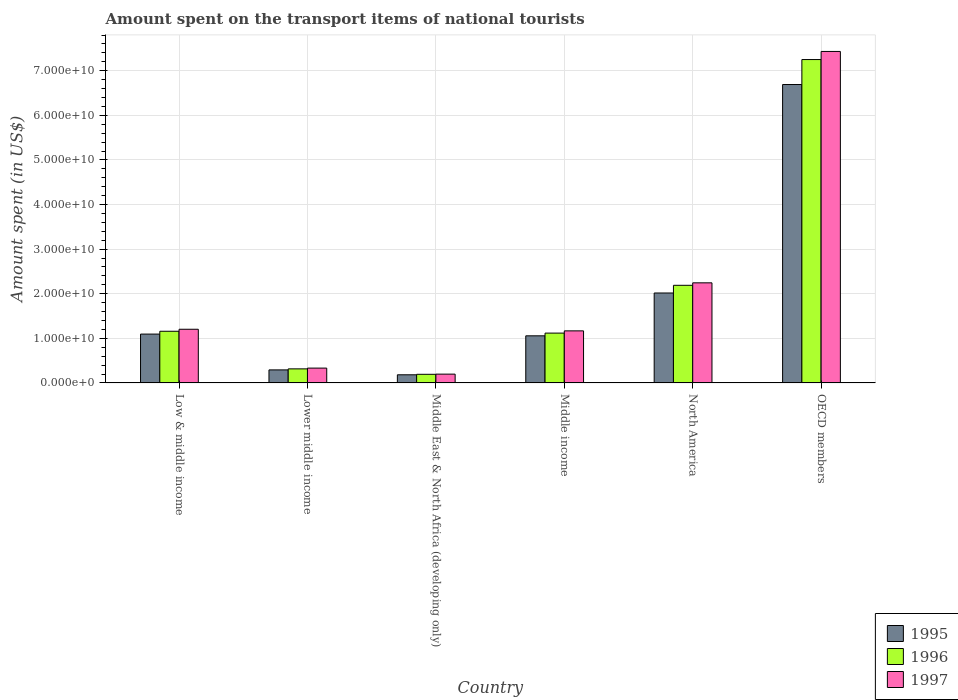How many different coloured bars are there?
Your answer should be very brief. 3. Are the number of bars on each tick of the X-axis equal?
Give a very brief answer. Yes. How many bars are there on the 1st tick from the right?
Provide a succinct answer. 3. What is the label of the 6th group of bars from the left?
Keep it short and to the point. OECD members. In how many cases, is the number of bars for a given country not equal to the number of legend labels?
Your response must be concise. 0. What is the amount spent on the transport items of national tourists in 1996 in Lower middle income?
Ensure brevity in your answer.  3.16e+09. Across all countries, what is the maximum amount spent on the transport items of national tourists in 1996?
Make the answer very short. 7.25e+1. Across all countries, what is the minimum amount spent on the transport items of national tourists in 1996?
Provide a short and direct response. 1.94e+09. In which country was the amount spent on the transport items of national tourists in 1995 minimum?
Ensure brevity in your answer.  Middle East & North Africa (developing only). What is the total amount spent on the transport items of national tourists in 1997 in the graph?
Offer a terse response. 1.26e+11. What is the difference between the amount spent on the transport items of national tourists in 1996 in Low & middle income and that in OECD members?
Your answer should be very brief. -6.09e+1. What is the difference between the amount spent on the transport items of national tourists in 1996 in North America and the amount spent on the transport items of national tourists in 1995 in OECD members?
Give a very brief answer. -4.50e+1. What is the average amount spent on the transport items of national tourists in 1997 per country?
Keep it short and to the point. 2.10e+1. What is the difference between the amount spent on the transport items of national tourists of/in 1996 and amount spent on the transport items of national tourists of/in 1995 in Lower middle income?
Keep it short and to the point. 2.31e+08. What is the ratio of the amount spent on the transport items of national tourists in 1995 in Middle East & North Africa (developing only) to that in OECD members?
Offer a very short reply. 0.03. Is the amount spent on the transport items of national tourists in 1996 in Low & middle income less than that in OECD members?
Keep it short and to the point. Yes. Is the difference between the amount spent on the transport items of national tourists in 1996 in Lower middle income and OECD members greater than the difference between the amount spent on the transport items of national tourists in 1995 in Lower middle income and OECD members?
Provide a short and direct response. No. What is the difference between the highest and the second highest amount spent on the transport items of national tourists in 1997?
Make the answer very short. 5.19e+1. What is the difference between the highest and the lowest amount spent on the transport items of national tourists in 1995?
Provide a short and direct response. 6.51e+1. In how many countries, is the amount spent on the transport items of national tourists in 1996 greater than the average amount spent on the transport items of national tourists in 1996 taken over all countries?
Offer a terse response. 2. Is the sum of the amount spent on the transport items of national tourists in 1996 in Middle East & North Africa (developing only) and North America greater than the maximum amount spent on the transport items of national tourists in 1997 across all countries?
Make the answer very short. No. What does the 1st bar from the right in OECD members represents?
Offer a terse response. 1997. Is it the case that in every country, the sum of the amount spent on the transport items of national tourists in 1997 and amount spent on the transport items of national tourists in 1995 is greater than the amount spent on the transport items of national tourists in 1996?
Give a very brief answer. Yes. How many bars are there?
Make the answer very short. 18. How many countries are there in the graph?
Your answer should be compact. 6. Does the graph contain any zero values?
Give a very brief answer. No. Does the graph contain grids?
Offer a terse response. Yes. How are the legend labels stacked?
Offer a terse response. Vertical. What is the title of the graph?
Provide a succinct answer. Amount spent on the transport items of national tourists. What is the label or title of the X-axis?
Your answer should be compact. Country. What is the label or title of the Y-axis?
Make the answer very short. Amount spent (in US$). What is the Amount spent (in US$) of 1995 in Low & middle income?
Your answer should be very brief. 1.10e+1. What is the Amount spent (in US$) of 1996 in Low & middle income?
Your answer should be very brief. 1.16e+1. What is the Amount spent (in US$) in 1997 in Low & middle income?
Make the answer very short. 1.20e+1. What is the Amount spent (in US$) of 1995 in Lower middle income?
Offer a very short reply. 2.92e+09. What is the Amount spent (in US$) in 1996 in Lower middle income?
Your answer should be very brief. 3.16e+09. What is the Amount spent (in US$) of 1997 in Lower middle income?
Your response must be concise. 3.33e+09. What is the Amount spent (in US$) of 1995 in Middle East & North Africa (developing only)?
Your response must be concise. 1.83e+09. What is the Amount spent (in US$) in 1996 in Middle East & North Africa (developing only)?
Your answer should be compact. 1.94e+09. What is the Amount spent (in US$) in 1997 in Middle East & North Africa (developing only)?
Keep it short and to the point. 1.97e+09. What is the Amount spent (in US$) of 1995 in Middle income?
Make the answer very short. 1.06e+1. What is the Amount spent (in US$) in 1996 in Middle income?
Provide a succinct answer. 1.12e+1. What is the Amount spent (in US$) in 1997 in Middle income?
Provide a succinct answer. 1.17e+1. What is the Amount spent (in US$) of 1995 in North America?
Ensure brevity in your answer.  2.02e+1. What is the Amount spent (in US$) in 1996 in North America?
Provide a short and direct response. 2.19e+1. What is the Amount spent (in US$) of 1997 in North America?
Offer a terse response. 2.24e+1. What is the Amount spent (in US$) of 1995 in OECD members?
Ensure brevity in your answer.  6.69e+1. What is the Amount spent (in US$) in 1996 in OECD members?
Provide a short and direct response. 7.25e+1. What is the Amount spent (in US$) in 1997 in OECD members?
Provide a succinct answer. 7.43e+1. Across all countries, what is the maximum Amount spent (in US$) in 1995?
Your response must be concise. 6.69e+1. Across all countries, what is the maximum Amount spent (in US$) of 1996?
Your answer should be very brief. 7.25e+1. Across all countries, what is the maximum Amount spent (in US$) of 1997?
Keep it short and to the point. 7.43e+1. Across all countries, what is the minimum Amount spent (in US$) of 1995?
Your response must be concise. 1.83e+09. Across all countries, what is the minimum Amount spent (in US$) in 1996?
Your response must be concise. 1.94e+09. Across all countries, what is the minimum Amount spent (in US$) in 1997?
Make the answer very short. 1.97e+09. What is the total Amount spent (in US$) of 1995 in the graph?
Give a very brief answer. 1.13e+11. What is the total Amount spent (in US$) of 1996 in the graph?
Your response must be concise. 1.22e+11. What is the total Amount spent (in US$) in 1997 in the graph?
Your response must be concise. 1.26e+11. What is the difference between the Amount spent (in US$) of 1995 in Low & middle income and that in Lower middle income?
Your answer should be very brief. 8.03e+09. What is the difference between the Amount spent (in US$) in 1996 in Low & middle income and that in Lower middle income?
Make the answer very short. 8.43e+09. What is the difference between the Amount spent (in US$) of 1997 in Low & middle income and that in Lower middle income?
Provide a short and direct response. 8.71e+09. What is the difference between the Amount spent (in US$) of 1995 in Low & middle income and that in Middle East & North Africa (developing only)?
Your answer should be very brief. 9.13e+09. What is the difference between the Amount spent (in US$) of 1996 in Low & middle income and that in Middle East & North Africa (developing only)?
Ensure brevity in your answer.  9.65e+09. What is the difference between the Amount spent (in US$) of 1997 in Low & middle income and that in Middle East & North Africa (developing only)?
Ensure brevity in your answer.  1.01e+1. What is the difference between the Amount spent (in US$) in 1995 in Low & middle income and that in Middle income?
Offer a terse response. 3.88e+08. What is the difference between the Amount spent (in US$) of 1996 in Low & middle income and that in Middle income?
Your answer should be very brief. 4.14e+08. What is the difference between the Amount spent (in US$) of 1997 in Low & middle income and that in Middle income?
Provide a short and direct response. 3.62e+08. What is the difference between the Amount spent (in US$) of 1995 in Low & middle income and that in North America?
Your answer should be very brief. -9.21e+09. What is the difference between the Amount spent (in US$) in 1996 in Low & middle income and that in North America?
Your answer should be very brief. -1.03e+1. What is the difference between the Amount spent (in US$) in 1997 in Low & middle income and that in North America?
Your response must be concise. -1.04e+1. What is the difference between the Amount spent (in US$) of 1995 in Low & middle income and that in OECD members?
Your response must be concise. -5.60e+1. What is the difference between the Amount spent (in US$) of 1996 in Low & middle income and that in OECD members?
Offer a terse response. -6.09e+1. What is the difference between the Amount spent (in US$) of 1997 in Low & middle income and that in OECD members?
Ensure brevity in your answer.  -6.23e+1. What is the difference between the Amount spent (in US$) in 1995 in Lower middle income and that in Middle East & North Africa (developing only)?
Your response must be concise. 1.10e+09. What is the difference between the Amount spent (in US$) in 1996 in Lower middle income and that in Middle East & North Africa (developing only)?
Ensure brevity in your answer.  1.22e+09. What is the difference between the Amount spent (in US$) in 1997 in Lower middle income and that in Middle East & North Africa (developing only)?
Your response must be concise. 1.35e+09. What is the difference between the Amount spent (in US$) of 1995 in Lower middle income and that in Middle income?
Your answer should be compact. -7.64e+09. What is the difference between the Amount spent (in US$) in 1996 in Lower middle income and that in Middle income?
Give a very brief answer. -8.02e+09. What is the difference between the Amount spent (in US$) in 1997 in Lower middle income and that in Middle income?
Keep it short and to the point. -8.35e+09. What is the difference between the Amount spent (in US$) of 1995 in Lower middle income and that in North America?
Your answer should be very brief. -1.72e+1. What is the difference between the Amount spent (in US$) in 1996 in Lower middle income and that in North America?
Provide a succinct answer. -1.87e+1. What is the difference between the Amount spent (in US$) in 1997 in Lower middle income and that in North America?
Offer a very short reply. -1.91e+1. What is the difference between the Amount spent (in US$) in 1995 in Lower middle income and that in OECD members?
Provide a succinct answer. -6.40e+1. What is the difference between the Amount spent (in US$) of 1996 in Lower middle income and that in OECD members?
Keep it short and to the point. -6.94e+1. What is the difference between the Amount spent (in US$) in 1997 in Lower middle income and that in OECD members?
Keep it short and to the point. -7.10e+1. What is the difference between the Amount spent (in US$) in 1995 in Middle East & North Africa (developing only) and that in Middle income?
Ensure brevity in your answer.  -8.74e+09. What is the difference between the Amount spent (in US$) of 1996 in Middle East & North Africa (developing only) and that in Middle income?
Give a very brief answer. -9.24e+09. What is the difference between the Amount spent (in US$) in 1997 in Middle East & North Africa (developing only) and that in Middle income?
Provide a short and direct response. -9.70e+09. What is the difference between the Amount spent (in US$) in 1995 in Middle East & North Africa (developing only) and that in North America?
Provide a short and direct response. -1.83e+1. What is the difference between the Amount spent (in US$) of 1996 in Middle East & North Africa (developing only) and that in North America?
Provide a succinct answer. -2.00e+1. What is the difference between the Amount spent (in US$) in 1997 in Middle East & North Africa (developing only) and that in North America?
Your response must be concise. -2.05e+1. What is the difference between the Amount spent (in US$) of 1995 in Middle East & North Africa (developing only) and that in OECD members?
Offer a terse response. -6.51e+1. What is the difference between the Amount spent (in US$) in 1996 in Middle East & North Africa (developing only) and that in OECD members?
Make the answer very short. -7.06e+1. What is the difference between the Amount spent (in US$) of 1997 in Middle East & North Africa (developing only) and that in OECD members?
Keep it short and to the point. -7.24e+1. What is the difference between the Amount spent (in US$) in 1995 in Middle income and that in North America?
Provide a succinct answer. -9.60e+09. What is the difference between the Amount spent (in US$) in 1996 in Middle income and that in North America?
Your response must be concise. -1.07e+1. What is the difference between the Amount spent (in US$) of 1997 in Middle income and that in North America?
Give a very brief answer. -1.08e+1. What is the difference between the Amount spent (in US$) of 1995 in Middle income and that in OECD members?
Ensure brevity in your answer.  -5.63e+1. What is the difference between the Amount spent (in US$) in 1996 in Middle income and that in OECD members?
Keep it short and to the point. -6.13e+1. What is the difference between the Amount spent (in US$) in 1997 in Middle income and that in OECD members?
Make the answer very short. -6.27e+1. What is the difference between the Amount spent (in US$) in 1995 in North America and that in OECD members?
Provide a succinct answer. -4.67e+1. What is the difference between the Amount spent (in US$) in 1996 in North America and that in OECD members?
Offer a terse response. -5.06e+1. What is the difference between the Amount spent (in US$) in 1997 in North America and that in OECD members?
Keep it short and to the point. -5.19e+1. What is the difference between the Amount spent (in US$) of 1995 in Low & middle income and the Amount spent (in US$) of 1996 in Lower middle income?
Your answer should be very brief. 7.80e+09. What is the difference between the Amount spent (in US$) of 1995 in Low & middle income and the Amount spent (in US$) of 1997 in Lower middle income?
Give a very brief answer. 7.63e+09. What is the difference between the Amount spent (in US$) in 1996 in Low & middle income and the Amount spent (in US$) in 1997 in Lower middle income?
Your response must be concise. 8.26e+09. What is the difference between the Amount spent (in US$) in 1995 in Low & middle income and the Amount spent (in US$) in 1996 in Middle East & North Africa (developing only)?
Offer a very short reply. 9.02e+09. What is the difference between the Amount spent (in US$) in 1995 in Low & middle income and the Amount spent (in US$) in 1997 in Middle East & North Africa (developing only)?
Make the answer very short. 8.98e+09. What is the difference between the Amount spent (in US$) of 1996 in Low & middle income and the Amount spent (in US$) of 1997 in Middle East & North Africa (developing only)?
Your answer should be compact. 9.61e+09. What is the difference between the Amount spent (in US$) of 1995 in Low & middle income and the Amount spent (in US$) of 1996 in Middle income?
Your answer should be compact. -2.19e+08. What is the difference between the Amount spent (in US$) in 1995 in Low & middle income and the Amount spent (in US$) in 1997 in Middle income?
Make the answer very short. -7.20e+08. What is the difference between the Amount spent (in US$) of 1996 in Low & middle income and the Amount spent (in US$) of 1997 in Middle income?
Your response must be concise. -8.74e+07. What is the difference between the Amount spent (in US$) in 1995 in Low & middle income and the Amount spent (in US$) in 1996 in North America?
Ensure brevity in your answer.  -1.09e+1. What is the difference between the Amount spent (in US$) in 1995 in Low & middle income and the Amount spent (in US$) in 1997 in North America?
Make the answer very short. -1.15e+1. What is the difference between the Amount spent (in US$) of 1996 in Low & middle income and the Amount spent (in US$) of 1997 in North America?
Provide a succinct answer. -1.09e+1. What is the difference between the Amount spent (in US$) of 1995 in Low & middle income and the Amount spent (in US$) of 1996 in OECD members?
Provide a succinct answer. -6.16e+1. What is the difference between the Amount spent (in US$) of 1995 in Low & middle income and the Amount spent (in US$) of 1997 in OECD members?
Offer a terse response. -6.34e+1. What is the difference between the Amount spent (in US$) of 1996 in Low & middle income and the Amount spent (in US$) of 1997 in OECD members?
Your answer should be very brief. -6.27e+1. What is the difference between the Amount spent (in US$) of 1995 in Lower middle income and the Amount spent (in US$) of 1996 in Middle East & North Africa (developing only)?
Keep it short and to the point. 9.90e+08. What is the difference between the Amount spent (in US$) in 1995 in Lower middle income and the Amount spent (in US$) in 1997 in Middle East & North Africa (developing only)?
Offer a terse response. 9.50e+08. What is the difference between the Amount spent (in US$) of 1996 in Lower middle income and the Amount spent (in US$) of 1997 in Middle East & North Africa (developing only)?
Give a very brief answer. 1.18e+09. What is the difference between the Amount spent (in US$) in 1995 in Lower middle income and the Amount spent (in US$) in 1996 in Middle income?
Give a very brief answer. -8.25e+09. What is the difference between the Amount spent (in US$) of 1995 in Lower middle income and the Amount spent (in US$) of 1997 in Middle income?
Keep it short and to the point. -8.75e+09. What is the difference between the Amount spent (in US$) of 1996 in Lower middle income and the Amount spent (in US$) of 1997 in Middle income?
Your answer should be compact. -8.52e+09. What is the difference between the Amount spent (in US$) of 1995 in Lower middle income and the Amount spent (in US$) of 1996 in North America?
Give a very brief answer. -1.90e+1. What is the difference between the Amount spent (in US$) in 1995 in Lower middle income and the Amount spent (in US$) in 1997 in North America?
Your answer should be very brief. -1.95e+1. What is the difference between the Amount spent (in US$) of 1996 in Lower middle income and the Amount spent (in US$) of 1997 in North America?
Offer a terse response. -1.93e+1. What is the difference between the Amount spent (in US$) in 1995 in Lower middle income and the Amount spent (in US$) in 1996 in OECD members?
Offer a terse response. -6.96e+1. What is the difference between the Amount spent (in US$) in 1995 in Lower middle income and the Amount spent (in US$) in 1997 in OECD members?
Offer a terse response. -7.14e+1. What is the difference between the Amount spent (in US$) in 1996 in Lower middle income and the Amount spent (in US$) in 1997 in OECD members?
Keep it short and to the point. -7.12e+1. What is the difference between the Amount spent (in US$) of 1995 in Middle East & North Africa (developing only) and the Amount spent (in US$) of 1996 in Middle income?
Give a very brief answer. -9.35e+09. What is the difference between the Amount spent (in US$) in 1995 in Middle East & North Africa (developing only) and the Amount spent (in US$) in 1997 in Middle income?
Your answer should be compact. -9.85e+09. What is the difference between the Amount spent (in US$) in 1996 in Middle East & North Africa (developing only) and the Amount spent (in US$) in 1997 in Middle income?
Keep it short and to the point. -9.74e+09. What is the difference between the Amount spent (in US$) of 1995 in Middle East & North Africa (developing only) and the Amount spent (in US$) of 1996 in North America?
Your answer should be compact. -2.01e+1. What is the difference between the Amount spent (in US$) in 1995 in Middle East & North Africa (developing only) and the Amount spent (in US$) in 1997 in North America?
Keep it short and to the point. -2.06e+1. What is the difference between the Amount spent (in US$) in 1996 in Middle East & North Africa (developing only) and the Amount spent (in US$) in 1997 in North America?
Make the answer very short. -2.05e+1. What is the difference between the Amount spent (in US$) in 1995 in Middle East & North Africa (developing only) and the Amount spent (in US$) in 1996 in OECD members?
Make the answer very short. -7.07e+1. What is the difference between the Amount spent (in US$) of 1995 in Middle East & North Africa (developing only) and the Amount spent (in US$) of 1997 in OECD members?
Provide a short and direct response. -7.25e+1. What is the difference between the Amount spent (in US$) of 1996 in Middle East & North Africa (developing only) and the Amount spent (in US$) of 1997 in OECD members?
Your response must be concise. -7.24e+1. What is the difference between the Amount spent (in US$) in 1995 in Middle income and the Amount spent (in US$) in 1996 in North America?
Make the answer very short. -1.13e+1. What is the difference between the Amount spent (in US$) in 1995 in Middle income and the Amount spent (in US$) in 1997 in North America?
Give a very brief answer. -1.19e+1. What is the difference between the Amount spent (in US$) in 1996 in Middle income and the Amount spent (in US$) in 1997 in North America?
Provide a short and direct response. -1.13e+1. What is the difference between the Amount spent (in US$) in 1995 in Middle income and the Amount spent (in US$) in 1996 in OECD members?
Provide a succinct answer. -6.19e+1. What is the difference between the Amount spent (in US$) of 1995 in Middle income and the Amount spent (in US$) of 1997 in OECD members?
Offer a terse response. -6.38e+1. What is the difference between the Amount spent (in US$) of 1996 in Middle income and the Amount spent (in US$) of 1997 in OECD members?
Provide a succinct answer. -6.32e+1. What is the difference between the Amount spent (in US$) of 1995 in North America and the Amount spent (in US$) of 1996 in OECD members?
Offer a very short reply. -5.23e+1. What is the difference between the Amount spent (in US$) of 1995 in North America and the Amount spent (in US$) of 1997 in OECD members?
Make the answer very short. -5.42e+1. What is the difference between the Amount spent (in US$) of 1996 in North America and the Amount spent (in US$) of 1997 in OECD members?
Make the answer very short. -5.24e+1. What is the average Amount spent (in US$) in 1995 per country?
Ensure brevity in your answer.  1.89e+1. What is the average Amount spent (in US$) in 1996 per country?
Your response must be concise. 2.04e+1. What is the average Amount spent (in US$) in 1997 per country?
Ensure brevity in your answer.  2.10e+1. What is the difference between the Amount spent (in US$) in 1995 and Amount spent (in US$) in 1996 in Low & middle income?
Provide a short and direct response. -6.33e+08. What is the difference between the Amount spent (in US$) in 1995 and Amount spent (in US$) in 1997 in Low & middle income?
Your answer should be compact. -1.08e+09. What is the difference between the Amount spent (in US$) of 1996 and Amount spent (in US$) of 1997 in Low & middle income?
Provide a short and direct response. -4.49e+08. What is the difference between the Amount spent (in US$) of 1995 and Amount spent (in US$) of 1996 in Lower middle income?
Your answer should be compact. -2.31e+08. What is the difference between the Amount spent (in US$) of 1995 and Amount spent (in US$) of 1997 in Lower middle income?
Make the answer very short. -4.03e+08. What is the difference between the Amount spent (in US$) of 1996 and Amount spent (in US$) of 1997 in Lower middle income?
Your response must be concise. -1.73e+08. What is the difference between the Amount spent (in US$) of 1995 and Amount spent (in US$) of 1996 in Middle East & North Africa (developing only)?
Your answer should be very brief. -1.08e+08. What is the difference between the Amount spent (in US$) of 1995 and Amount spent (in US$) of 1997 in Middle East & North Africa (developing only)?
Your response must be concise. -1.47e+08. What is the difference between the Amount spent (in US$) of 1996 and Amount spent (in US$) of 1997 in Middle East & North Africa (developing only)?
Ensure brevity in your answer.  -3.92e+07. What is the difference between the Amount spent (in US$) in 1995 and Amount spent (in US$) in 1996 in Middle income?
Give a very brief answer. -6.08e+08. What is the difference between the Amount spent (in US$) of 1995 and Amount spent (in US$) of 1997 in Middle income?
Your answer should be compact. -1.11e+09. What is the difference between the Amount spent (in US$) in 1996 and Amount spent (in US$) in 1997 in Middle income?
Your answer should be compact. -5.01e+08. What is the difference between the Amount spent (in US$) in 1995 and Amount spent (in US$) in 1996 in North America?
Provide a succinct answer. -1.72e+09. What is the difference between the Amount spent (in US$) in 1995 and Amount spent (in US$) in 1997 in North America?
Your response must be concise. -2.28e+09. What is the difference between the Amount spent (in US$) of 1996 and Amount spent (in US$) of 1997 in North America?
Make the answer very short. -5.53e+08. What is the difference between the Amount spent (in US$) of 1995 and Amount spent (in US$) of 1996 in OECD members?
Offer a very short reply. -5.60e+09. What is the difference between the Amount spent (in US$) in 1995 and Amount spent (in US$) in 1997 in OECD members?
Your answer should be compact. -7.41e+09. What is the difference between the Amount spent (in US$) of 1996 and Amount spent (in US$) of 1997 in OECD members?
Offer a very short reply. -1.82e+09. What is the ratio of the Amount spent (in US$) in 1995 in Low & middle income to that in Lower middle income?
Your answer should be compact. 3.75. What is the ratio of the Amount spent (in US$) in 1996 in Low & middle income to that in Lower middle income?
Provide a short and direct response. 3.67. What is the ratio of the Amount spent (in US$) of 1997 in Low & middle income to that in Lower middle income?
Provide a succinct answer. 3.62. What is the ratio of the Amount spent (in US$) in 1995 in Low & middle income to that in Middle East & North Africa (developing only)?
Make the answer very short. 5.99. What is the ratio of the Amount spent (in US$) in 1996 in Low & middle income to that in Middle East & North Africa (developing only)?
Make the answer very short. 5.99. What is the ratio of the Amount spent (in US$) of 1997 in Low & middle income to that in Middle East & North Africa (developing only)?
Give a very brief answer. 6.1. What is the ratio of the Amount spent (in US$) of 1995 in Low & middle income to that in Middle income?
Offer a very short reply. 1.04. What is the ratio of the Amount spent (in US$) in 1996 in Low & middle income to that in Middle income?
Give a very brief answer. 1.04. What is the ratio of the Amount spent (in US$) in 1997 in Low & middle income to that in Middle income?
Provide a succinct answer. 1.03. What is the ratio of the Amount spent (in US$) of 1995 in Low & middle income to that in North America?
Your response must be concise. 0.54. What is the ratio of the Amount spent (in US$) in 1996 in Low & middle income to that in North America?
Provide a succinct answer. 0.53. What is the ratio of the Amount spent (in US$) of 1997 in Low & middle income to that in North America?
Your answer should be very brief. 0.54. What is the ratio of the Amount spent (in US$) in 1995 in Low & middle income to that in OECD members?
Your answer should be compact. 0.16. What is the ratio of the Amount spent (in US$) of 1996 in Low & middle income to that in OECD members?
Offer a very short reply. 0.16. What is the ratio of the Amount spent (in US$) in 1997 in Low & middle income to that in OECD members?
Your response must be concise. 0.16. What is the ratio of the Amount spent (in US$) in 1995 in Lower middle income to that in Middle East & North Africa (developing only)?
Give a very brief answer. 1.6. What is the ratio of the Amount spent (in US$) of 1996 in Lower middle income to that in Middle East & North Africa (developing only)?
Make the answer very short. 1.63. What is the ratio of the Amount spent (in US$) of 1997 in Lower middle income to that in Middle East & North Africa (developing only)?
Offer a very short reply. 1.69. What is the ratio of the Amount spent (in US$) of 1995 in Lower middle income to that in Middle income?
Offer a very short reply. 0.28. What is the ratio of the Amount spent (in US$) of 1996 in Lower middle income to that in Middle income?
Offer a terse response. 0.28. What is the ratio of the Amount spent (in US$) of 1997 in Lower middle income to that in Middle income?
Ensure brevity in your answer.  0.29. What is the ratio of the Amount spent (in US$) of 1995 in Lower middle income to that in North America?
Provide a short and direct response. 0.14. What is the ratio of the Amount spent (in US$) of 1996 in Lower middle income to that in North America?
Ensure brevity in your answer.  0.14. What is the ratio of the Amount spent (in US$) in 1997 in Lower middle income to that in North America?
Ensure brevity in your answer.  0.15. What is the ratio of the Amount spent (in US$) in 1995 in Lower middle income to that in OECD members?
Your response must be concise. 0.04. What is the ratio of the Amount spent (in US$) of 1996 in Lower middle income to that in OECD members?
Your answer should be compact. 0.04. What is the ratio of the Amount spent (in US$) in 1997 in Lower middle income to that in OECD members?
Keep it short and to the point. 0.04. What is the ratio of the Amount spent (in US$) of 1995 in Middle East & North Africa (developing only) to that in Middle income?
Keep it short and to the point. 0.17. What is the ratio of the Amount spent (in US$) in 1996 in Middle East & North Africa (developing only) to that in Middle income?
Your response must be concise. 0.17. What is the ratio of the Amount spent (in US$) of 1997 in Middle East & North Africa (developing only) to that in Middle income?
Provide a succinct answer. 0.17. What is the ratio of the Amount spent (in US$) in 1995 in Middle East & North Africa (developing only) to that in North America?
Provide a succinct answer. 0.09. What is the ratio of the Amount spent (in US$) of 1996 in Middle East & North Africa (developing only) to that in North America?
Make the answer very short. 0.09. What is the ratio of the Amount spent (in US$) in 1997 in Middle East & North Africa (developing only) to that in North America?
Your answer should be compact. 0.09. What is the ratio of the Amount spent (in US$) in 1995 in Middle East & North Africa (developing only) to that in OECD members?
Your answer should be compact. 0.03. What is the ratio of the Amount spent (in US$) in 1996 in Middle East & North Africa (developing only) to that in OECD members?
Your response must be concise. 0.03. What is the ratio of the Amount spent (in US$) in 1997 in Middle East & North Africa (developing only) to that in OECD members?
Offer a very short reply. 0.03. What is the ratio of the Amount spent (in US$) of 1995 in Middle income to that in North America?
Your response must be concise. 0.52. What is the ratio of the Amount spent (in US$) in 1996 in Middle income to that in North America?
Give a very brief answer. 0.51. What is the ratio of the Amount spent (in US$) of 1997 in Middle income to that in North America?
Your response must be concise. 0.52. What is the ratio of the Amount spent (in US$) in 1995 in Middle income to that in OECD members?
Your answer should be compact. 0.16. What is the ratio of the Amount spent (in US$) in 1996 in Middle income to that in OECD members?
Make the answer very short. 0.15. What is the ratio of the Amount spent (in US$) of 1997 in Middle income to that in OECD members?
Ensure brevity in your answer.  0.16. What is the ratio of the Amount spent (in US$) in 1995 in North America to that in OECD members?
Give a very brief answer. 0.3. What is the ratio of the Amount spent (in US$) in 1996 in North America to that in OECD members?
Make the answer very short. 0.3. What is the ratio of the Amount spent (in US$) in 1997 in North America to that in OECD members?
Provide a succinct answer. 0.3. What is the difference between the highest and the second highest Amount spent (in US$) of 1995?
Give a very brief answer. 4.67e+1. What is the difference between the highest and the second highest Amount spent (in US$) of 1996?
Provide a short and direct response. 5.06e+1. What is the difference between the highest and the second highest Amount spent (in US$) in 1997?
Provide a succinct answer. 5.19e+1. What is the difference between the highest and the lowest Amount spent (in US$) in 1995?
Give a very brief answer. 6.51e+1. What is the difference between the highest and the lowest Amount spent (in US$) in 1996?
Ensure brevity in your answer.  7.06e+1. What is the difference between the highest and the lowest Amount spent (in US$) in 1997?
Make the answer very short. 7.24e+1. 